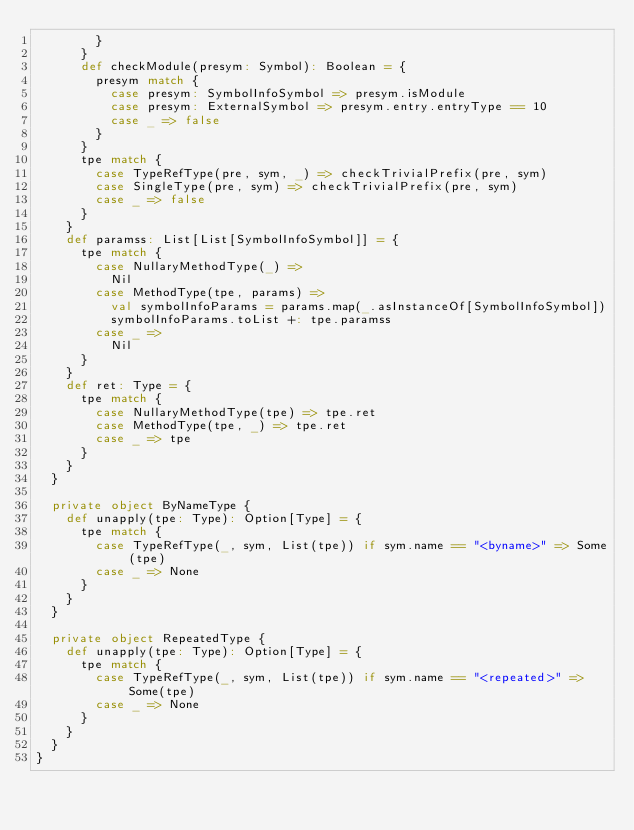Convert code to text. <code><loc_0><loc_0><loc_500><loc_500><_Scala_>        }
      }
      def checkModule(presym: Symbol): Boolean = {
        presym match {
          case presym: SymbolInfoSymbol => presym.isModule
          case presym: ExternalSymbol => presym.entry.entryType == 10
          case _ => false
        }
      }
      tpe match {
        case TypeRefType(pre, sym, _) => checkTrivialPrefix(pre, sym)
        case SingleType(pre, sym) => checkTrivialPrefix(pre, sym)
        case _ => false
      }
    }
    def paramss: List[List[SymbolInfoSymbol]] = {
      tpe match {
        case NullaryMethodType(_) =>
          Nil
        case MethodType(tpe, params) =>
          val symbolInfoParams = params.map(_.asInstanceOf[SymbolInfoSymbol])
          symbolInfoParams.toList +: tpe.paramss
        case _ =>
          Nil
      }
    }
    def ret: Type = {
      tpe match {
        case NullaryMethodType(tpe) => tpe.ret
        case MethodType(tpe, _) => tpe.ret
        case _ => tpe
      }
    }
  }

  private object ByNameType {
    def unapply(tpe: Type): Option[Type] = {
      tpe match {
        case TypeRefType(_, sym, List(tpe)) if sym.name == "<byname>" => Some(tpe)
        case _ => None
      }
    }
  }

  private object RepeatedType {
    def unapply(tpe: Type): Option[Type] = {
      tpe match {
        case TypeRefType(_, sym, List(tpe)) if sym.name == "<repeated>" => Some(tpe)
        case _ => None
      }
    }
  }
}
</code> 